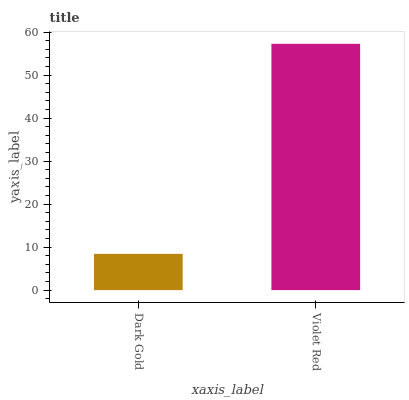Is Dark Gold the minimum?
Answer yes or no. Yes. Is Violet Red the maximum?
Answer yes or no. Yes. Is Violet Red the minimum?
Answer yes or no. No. Is Violet Red greater than Dark Gold?
Answer yes or no. Yes. Is Dark Gold less than Violet Red?
Answer yes or no. Yes. Is Dark Gold greater than Violet Red?
Answer yes or no. No. Is Violet Red less than Dark Gold?
Answer yes or no. No. Is Violet Red the high median?
Answer yes or no. Yes. Is Dark Gold the low median?
Answer yes or no. Yes. Is Dark Gold the high median?
Answer yes or no. No. Is Violet Red the low median?
Answer yes or no. No. 